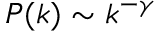<formula> <loc_0><loc_0><loc_500><loc_500>P ( k ) \sim k ^ { - \gamma }</formula> 